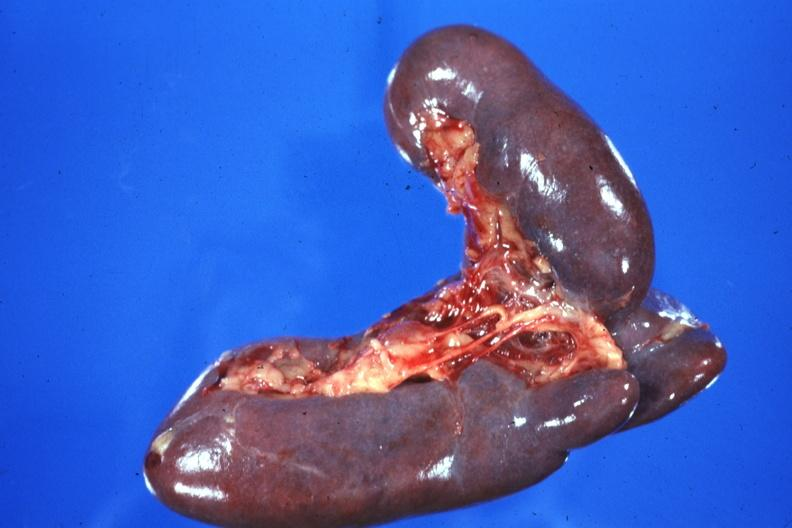what is present?
Answer the question using a single word or phrase. Hematologic 